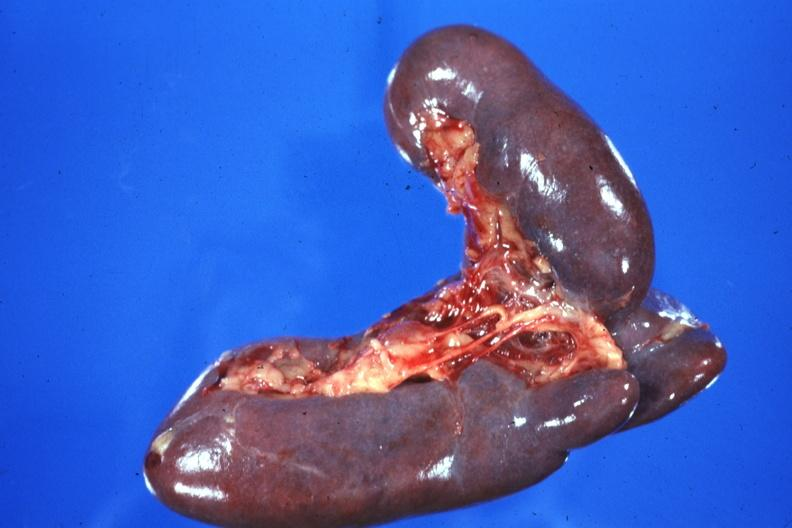what is present?
Answer the question using a single word or phrase. Hematologic 